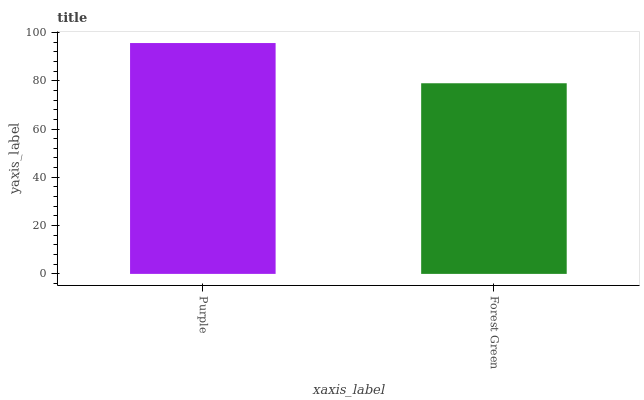Is Forest Green the minimum?
Answer yes or no. Yes. Is Purple the maximum?
Answer yes or no. Yes. Is Forest Green the maximum?
Answer yes or no. No. Is Purple greater than Forest Green?
Answer yes or no. Yes. Is Forest Green less than Purple?
Answer yes or no. Yes. Is Forest Green greater than Purple?
Answer yes or no. No. Is Purple less than Forest Green?
Answer yes or no. No. Is Purple the high median?
Answer yes or no. Yes. Is Forest Green the low median?
Answer yes or no. Yes. Is Forest Green the high median?
Answer yes or no. No. Is Purple the low median?
Answer yes or no. No. 